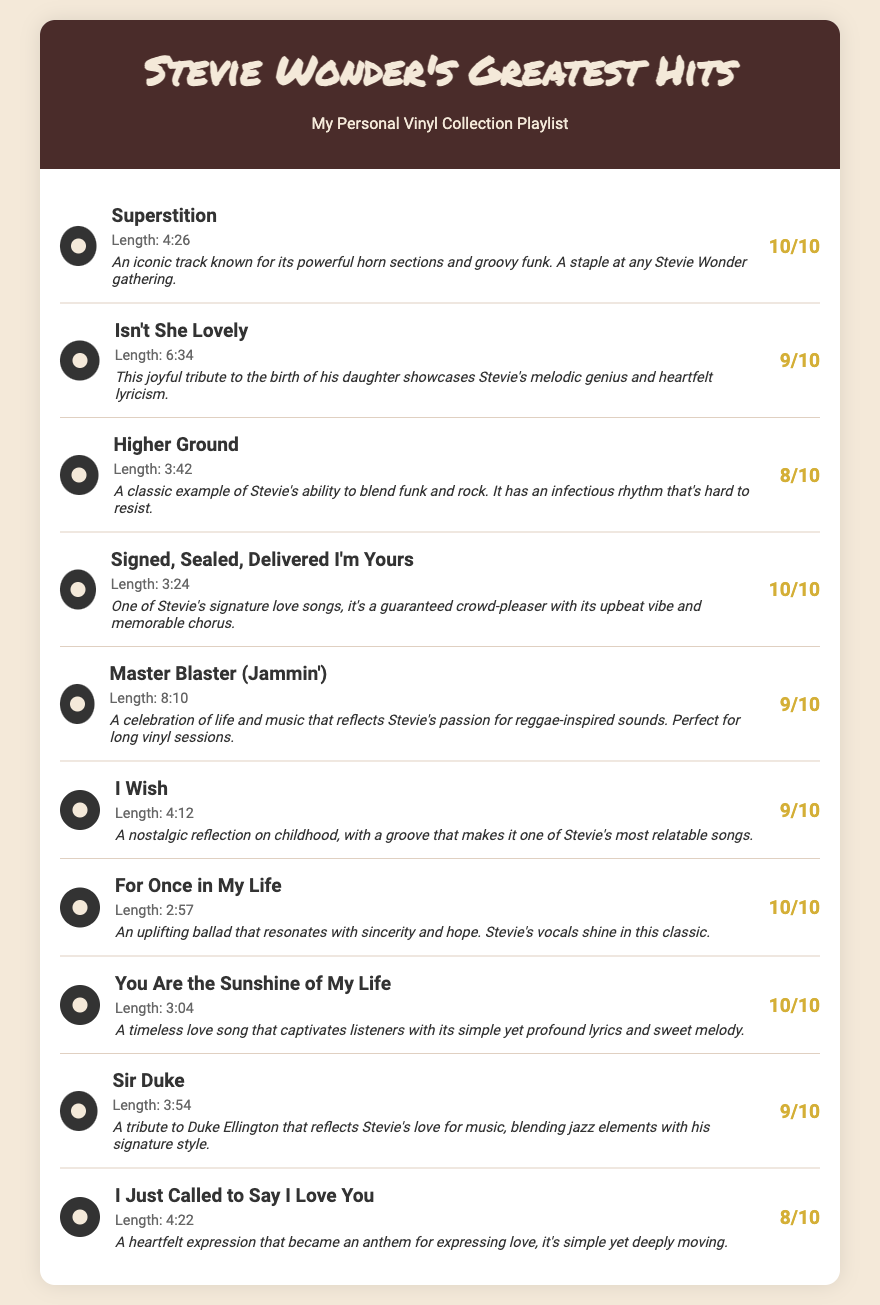What is the title of the first song in the playlist? The first song in the playlist is listed at the top of the section, which is "Superstition."
Answer: Superstition How long is the track "Isn't She Lovely"? The length of "Isn't She Lovely" is provided right next to the song title, which is 6:34.
Answer: 6:34 What rating did I give "Sir Duke"? The rating for "Sir Duke" is found next to the song title and is indicated as 9/10.
Answer: 9/10 Which song has the longest track length? By comparing the lengths listed, the longest track is "Master Blaster (Jammin')" at 8:10.
Answer: 8:10 What common theme is present in the notes for "For Once in My Life" and "You Are the Sunshine of My Life"? Both songs emphasize positivity and heartfelt emotions in their descriptions, suggesting a theme of love and hope.
Answer: Love and hope Which song is primarily a tribute to someone and who? The song "Sir Duke" is a tribute to Duke Ellington, as stated in its notes section.
Answer: Duke Ellington How many songs in this playlist received a rating of 10/10? By counting the ratings provided, a total of 5 songs were rated 10/10.
Answer: 5 What genre influences are mentioned for "Higher Ground"? The notes for "Higher Ground" mention the blend of funk and rock as its key influences.
Answer: Funk and rock Which song is known as a crowd-pleaser? The song "Signed, Sealed, Delivered I'm Yours" is highlighted in the notes as a guaranteed crowd-pleaser.
Answer: Signed, Sealed, Delivered I'm Yours 